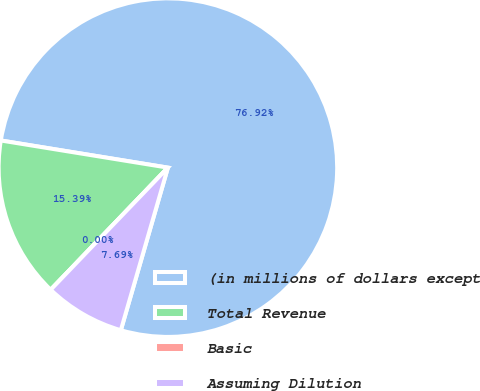<chart> <loc_0><loc_0><loc_500><loc_500><pie_chart><fcel>(in millions of dollars except<fcel>Total Revenue<fcel>Basic<fcel>Assuming Dilution<nl><fcel>76.92%<fcel>15.39%<fcel>0.0%<fcel>7.69%<nl></chart> 